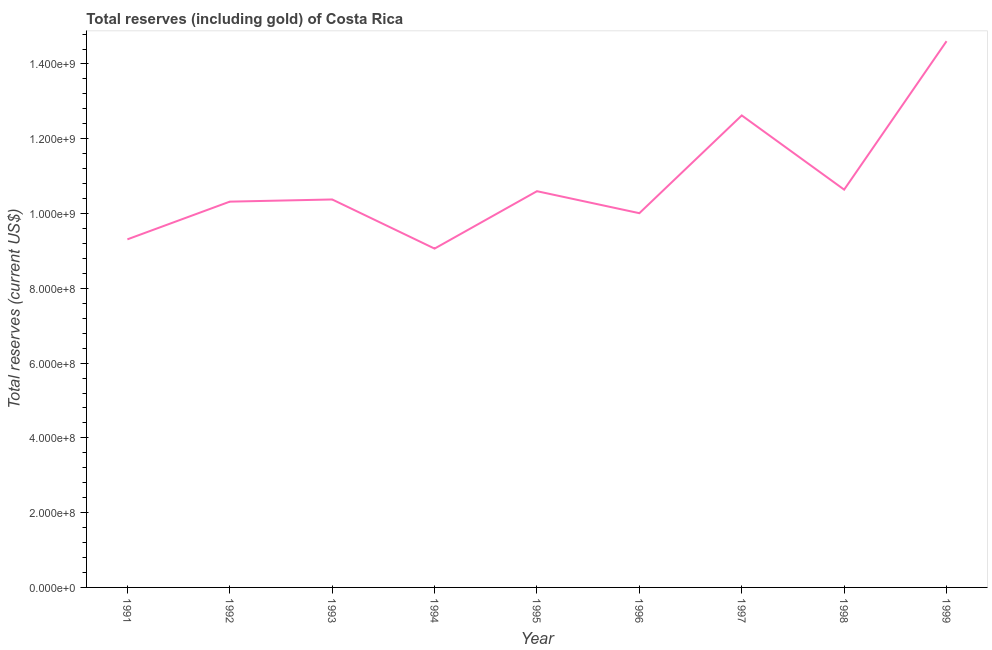What is the total reserves (including gold) in 1996?
Offer a very short reply. 1.00e+09. Across all years, what is the maximum total reserves (including gold)?
Provide a succinct answer. 1.46e+09. Across all years, what is the minimum total reserves (including gold)?
Keep it short and to the point. 9.06e+08. In which year was the total reserves (including gold) maximum?
Ensure brevity in your answer.  1999. What is the sum of the total reserves (including gold)?
Provide a short and direct response. 9.75e+09. What is the difference between the total reserves (including gold) in 1993 and 1995?
Your answer should be very brief. -2.21e+07. What is the average total reserves (including gold) per year?
Make the answer very short. 1.08e+09. What is the median total reserves (including gold)?
Your answer should be very brief. 1.04e+09. In how many years, is the total reserves (including gold) greater than 320000000 US$?
Provide a succinct answer. 9. What is the ratio of the total reserves (including gold) in 1995 to that in 1998?
Provide a short and direct response. 1. Is the total reserves (including gold) in 1992 less than that in 1994?
Your response must be concise. No. What is the difference between the highest and the second highest total reserves (including gold)?
Provide a short and direct response. 1.99e+08. What is the difference between the highest and the lowest total reserves (including gold)?
Your response must be concise. 5.55e+08. How many lines are there?
Offer a very short reply. 1. Does the graph contain any zero values?
Make the answer very short. No. Does the graph contain grids?
Make the answer very short. No. What is the title of the graph?
Your response must be concise. Total reserves (including gold) of Costa Rica. What is the label or title of the Y-axis?
Offer a terse response. Total reserves (current US$). What is the Total reserves (current US$) of 1991?
Offer a terse response. 9.31e+08. What is the Total reserves (current US$) of 1992?
Your answer should be compact. 1.03e+09. What is the Total reserves (current US$) of 1993?
Offer a terse response. 1.04e+09. What is the Total reserves (current US$) in 1994?
Make the answer very short. 9.06e+08. What is the Total reserves (current US$) in 1995?
Your answer should be very brief. 1.06e+09. What is the Total reserves (current US$) of 1996?
Provide a succinct answer. 1.00e+09. What is the Total reserves (current US$) of 1997?
Offer a terse response. 1.26e+09. What is the Total reserves (current US$) in 1998?
Ensure brevity in your answer.  1.06e+09. What is the Total reserves (current US$) in 1999?
Provide a succinct answer. 1.46e+09. What is the difference between the Total reserves (current US$) in 1991 and 1992?
Provide a succinct answer. -1.01e+08. What is the difference between the Total reserves (current US$) in 1991 and 1993?
Your answer should be compact. -1.07e+08. What is the difference between the Total reserves (current US$) in 1991 and 1994?
Provide a succinct answer. 2.48e+07. What is the difference between the Total reserves (current US$) in 1991 and 1995?
Give a very brief answer. -1.29e+08. What is the difference between the Total reserves (current US$) in 1991 and 1996?
Offer a terse response. -6.99e+07. What is the difference between the Total reserves (current US$) in 1991 and 1997?
Provide a short and direct response. -3.31e+08. What is the difference between the Total reserves (current US$) in 1991 and 1998?
Offer a very short reply. -1.33e+08. What is the difference between the Total reserves (current US$) in 1991 and 1999?
Provide a short and direct response. -5.30e+08. What is the difference between the Total reserves (current US$) in 1992 and 1993?
Give a very brief answer. -5.81e+06. What is the difference between the Total reserves (current US$) in 1992 and 1994?
Your answer should be compact. 1.26e+08. What is the difference between the Total reserves (current US$) in 1992 and 1995?
Offer a terse response. -2.79e+07. What is the difference between the Total reserves (current US$) in 1992 and 1996?
Your response must be concise. 3.09e+07. What is the difference between the Total reserves (current US$) in 1992 and 1997?
Provide a short and direct response. -2.31e+08. What is the difference between the Total reserves (current US$) in 1992 and 1998?
Your answer should be compact. -3.21e+07. What is the difference between the Total reserves (current US$) in 1992 and 1999?
Make the answer very short. -4.29e+08. What is the difference between the Total reserves (current US$) in 1993 and 1994?
Offer a very short reply. 1.31e+08. What is the difference between the Total reserves (current US$) in 1993 and 1995?
Your answer should be very brief. -2.21e+07. What is the difference between the Total reserves (current US$) in 1993 and 1996?
Keep it short and to the point. 3.67e+07. What is the difference between the Total reserves (current US$) in 1993 and 1997?
Offer a terse response. -2.25e+08. What is the difference between the Total reserves (current US$) in 1993 and 1998?
Ensure brevity in your answer.  -2.63e+07. What is the difference between the Total reserves (current US$) in 1993 and 1999?
Keep it short and to the point. -4.23e+08. What is the difference between the Total reserves (current US$) in 1994 and 1995?
Provide a short and direct response. -1.54e+08. What is the difference between the Total reserves (current US$) in 1994 and 1996?
Your answer should be very brief. -9.47e+07. What is the difference between the Total reserves (current US$) in 1994 and 1997?
Offer a terse response. -3.56e+08. What is the difference between the Total reserves (current US$) in 1994 and 1998?
Make the answer very short. -1.58e+08. What is the difference between the Total reserves (current US$) in 1994 and 1999?
Keep it short and to the point. -5.55e+08. What is the difference between the Total reserves (current US$) in 1995 and 1996?
Give a very brief answer. 5.88e+07. What is the difference between the Total reserves (current US$) in 1995 and 1997?
Your answer should be very brief. -2.03e+08. What is the difference between the Total reserves (current US$) in 1995 and 1998?
Your answer should be very brief. -4.18e+06. What is the difference between the Total reserves (current US$) in 1995 and 1999?
Provide a short and direct response. -4.01e+08. What is the difference between the Total reserves (current US$) in 1996 and 1997?
Make the answer very short. -2.61e+08. What is the difference between the Total reserves (current US$) in 1996 and 1998?
Your answer should be compact. -6.30e+07. What is the difference between the Total reserves (current US$) in 1996 and 1999?
Keep it short and to the point. -4.60e+08. What is the difference between the Total reserves (current US$) in 1997 and 1998?
Offer a terse response. 1.98e+08. What is the difference between the Total reserves (current US$) in 1997 and 1999?
Make the answer very short. -1.99e+08. What is the difference between the Total reserves (current US$) in 1998 and 1999?
Keep it short and to the point. -3.97e+08. What is the ratio of the Total reserves (current US$) in 1991 to that in 1992?
Offer a very short reply. 0.9. What is the ratio of the Total reserves (current US$) in 1991 to that in 1993?
Provide a succinct answer. 0.9. What is the ratio of the Total reserves (current US$) in 1991 to that in 1995?
Keep it short and to the point. 0.88. What is the ratio of the Total reserves (current US$) in 1991 to that in 1997?
Offer a very short reply. 0.74. What is the ratio of the Total reserves (current US$) in 1991 to that in 1999?
Provide a succinct answer. 0.64. What is the ratio of the Total reserves (current US$) in 1992 to that in 1994?
Give a very brief answer. 1.14. What is the ratio of the Total reserves (current US$) in 1992 to that in 1996?
Your answer should be very brief. 1.03. What is the ratio of the Total reserves (current US$) in 1992 to that in 1997?
Your answer should be very brief. 0.82. What is the ratio of the Total reserves (current US$) in 1992 to that in 1999?
Your response must be concise. 0.71. What is the ratio of the Total reserves (current US$) in 1993 to that in 1994?
Ensure brevity in your answer.  1.15. What is the ratio of the Total reserves (current US$) in 1993 to that in 1996?
Your answer should be compact. 1.04. What is the ratio of the Total reserves (current US$) in 1993 to that in 1997?
Provide a succinct answer. 0.82. What is the ratio of the Total reserves (current US$) in 1993 to that in 1998?
Provide a succinct answer. 0.97. What is the ratio of the Total reserves (current US$) in 1993 to that in 1999?
Provide a succinct answer. 0.71. What is the ratio of the Total reserves (current US$) in 1994 to that in 1995?
Keep it short and to the point. 0.85. What is the ratio of the Total reserves (current US$) in 1994 to that in 1996?
Offer a very short reply. 0.91. What is the ratio of the Total reserves (current US$) in 1994 to that in 1997?
Your response must be concise. 0.72. What is the ratio of the Total reserves (current US$) in 1994 to that in 1998?
Your answer should be very brief. 0.85. What is the ratio of the Total reserves (current US$) in 1994 to that in 1999?
Ensure brevity in your answer.  0.62. What is the ratio of the Total reserves (current US$) in 1995 to that in 1996?
Your answer should be compact. 1.06. What is the ratio of the Total reserves (current US$) in 1995 to that in 1997?
Keep it short and to the point. 0.84. What is the ratio of the Total reserves (current US$) in 1995 to that in 1998?
Keep it short and to the point. 1. What is the ratio of the Total reserves (current US$) in 1995 to that in 1999?
Provide a succinct answer. 0.72. What is the ratio of the Total reserves (current US$) in 1996 to that in 1997?
Offer a terse response. 0.79. What is the ratio of the Total reserves (current US$) in 1996 to that in 1998?
Keep it short and to the point. 0.94. What is the ratio of the Total reserves (current US$) in 1996 to that in 1999?
Your answer should be very brief. 0.69. What is the ratio of the Total reserves (current US$) in 1997 to that in 1998?
Your answer should be very brief. 1.19. What is the ratio of the Total reserves (current US$) in 1997 to that in 1999?
Provide a succinct answer. 0.86. What is the ratio of the Total reserves (current US$) in 1998 to that in 1999?
Your response must be concise. 0.73. 